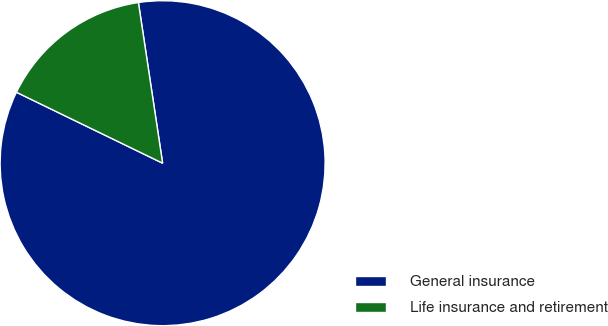Convert chart. <chart><loc_0><loc_0><loc_500><loc_500><pie_chart><fcel>General insurance<fcel>Life insurance and retirement<nl><fcel>84.57%<fcel>15.43%<nl></chart> 